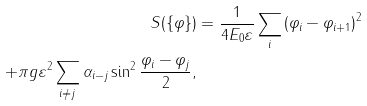Convert formula to latex. <formula><loc_0><loc_0><loc_500><loc_500>S ( \{ \varphi \} ) & = \frac { 1 } { 4 E _ { 0 } \varepsilon } \sum _ { i } \left ( \varphi _ { i } - \varphi _ { i + 1 } \right ) ^ { 2 } \\ + \pi g \varepsilon ^ { 2 } \sum _ { i \neq j } \alpha _ { i - j } \sin ^ { 2 } \frac { \varphi _ { i } - \varphi _ { j } } { 2 } ,</formula> 